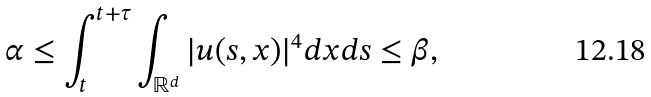<formula> <loc_0><loc_0><loc_500><loc_500>\alpha \leq \int _ { t } ^ { t + \tau } \int _ { \mathbb { R } ^ { d } } | u ( s , x ) | ^ { 4 } d x d s \leq \beta ,</formula> 